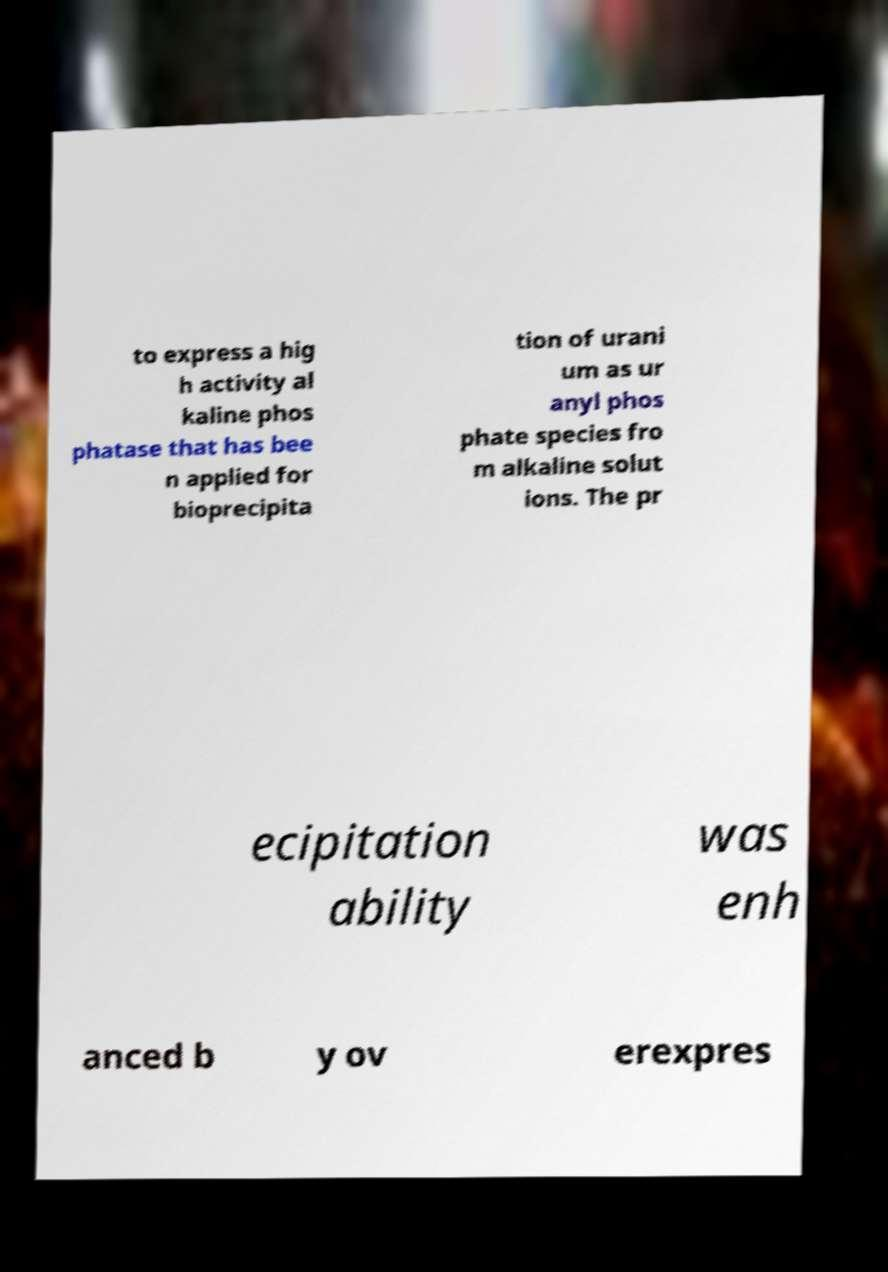I need the written content from this picture converted into text. Can you do that? to express a hig h activity al kaline phos phatase that has bee n applied for bioprecipita tion of urani um as ur anyl phos phate species fro m alkaline solut ions. The pr ecipitation ability was enh anced b y ov erexpres 